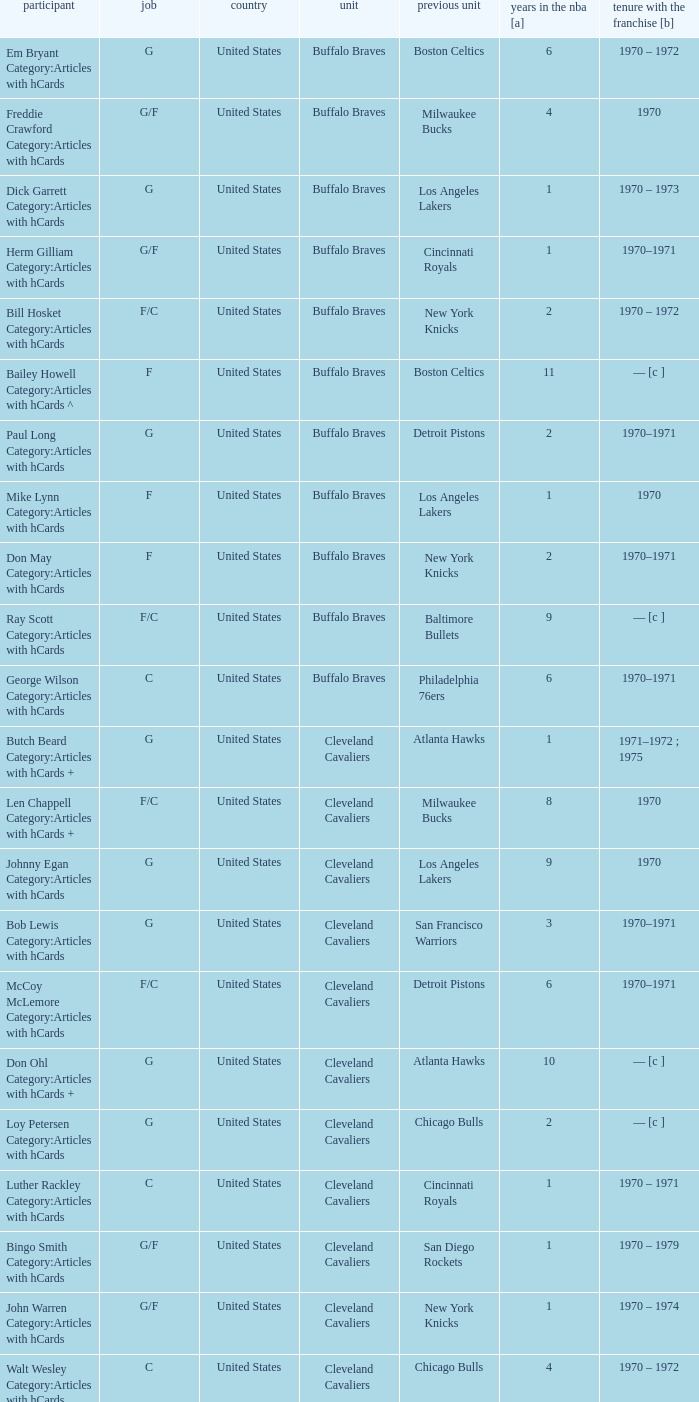Who is the player from the Buffalo Braves with the previous team Los Angeles Lakers and a career with the franchase in 1970? Mike Lynn Category:Articles with hCards. 